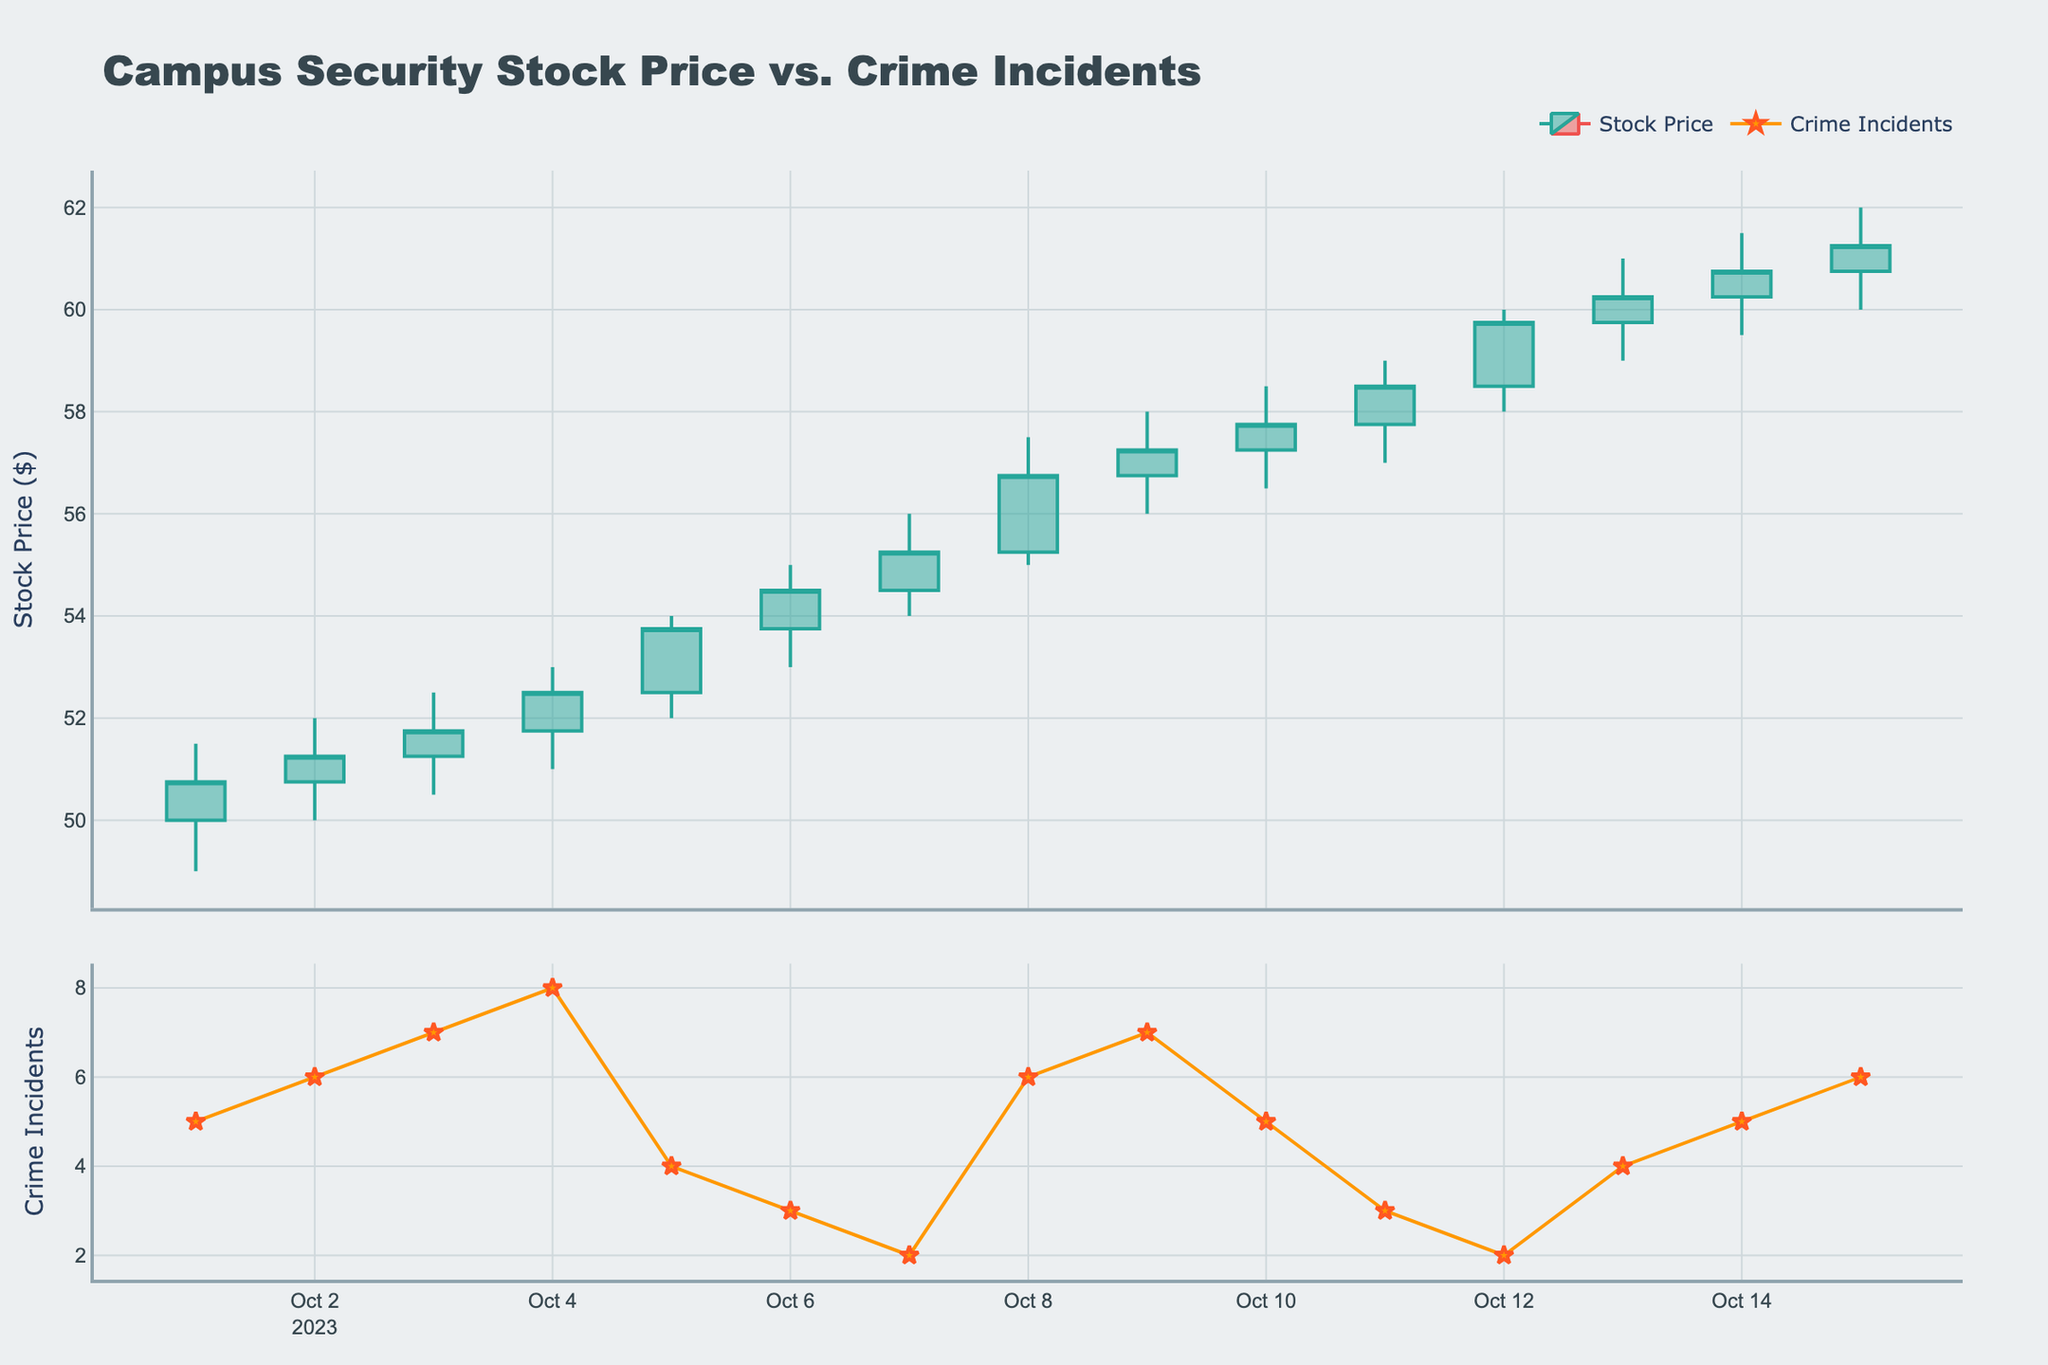What is the title of the figure? The title of the figure is displayed at the top and is usually descriptive of what the plot is showing. Here, it is “Campus Security Stock Price vs. Crime Incidents.”
Answer: Campus Security Stock Price vs. Crime Incidents How many data points are displayed for crime incidents? The number of data points can be counted from the scatter plot in the second subplot. We have one data point for each date listed, totaling fifteen dates.
Answer: 15 What is the color of the increasing stock price candlestick lines? The color of the increasing stock price candlestick lines can be observed from the legend or by looking at the candlestick lines that represent price increases. These lines are colored green.
Answer: Green Which day had the highest closing stock price? To find the day with the highest closing stock price, look at the closing prices (the top end of the candlestick body for increasing lines and the bottom end for decreasing lines). October 15th has the highest closing price at $61.25.
Answer: October 15 How does the stock price trend correlate with crime incidents from October 1st to October 7th? From October 1st to October 7th, the stock price increases as we observe in the candlestick plot. At the same time, the number of crime incidents decreases from 5 to 2. This shows a negative correlation between stock price and crime incidents during these days.
Answer: Negative correlation What was the closing stock price on the day with the highest crime incidents? The highest number of crime incidents is 8 on October 4th. The closing stock price on this date can be found by looking at the close value on the candlestick plot on October 4th, which is $52.50.
Answer: $52.50 On which dates were there only 2 crime incidents, and how did the stock price change on these dates? The dates with 2 crime incidents are October 7th and October 12th. On these dates, check the candlestick plots to see the stock price movement. On October 7th, the price increased from $54.50 to $55.25, and on October 12th, it increased from $58.50 to $59.75.
Answer: October 7 and October 12; prices increased What is the overall trend of crime incidents compared to the overall trend of stock prices throughout the period shown? By observing the entire plot, crime incidents have a general decreasing trend, while the stock prices show an overall increasing trend. This indicates an inverse relationship between the two metrics.
Answer: Inverse relationship How many days had crime incidents equal to or greater than 6? Identify each day with crime incidents by looking at the scatter plot in the second subplot. Count each day where the crime incidents are 6 or more. There are six such days: October 2, October 3, October 4, October 8, October 9, and October 15.
Answer: 6 